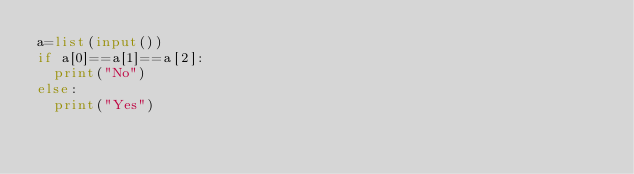<code> <loc_0><loc_0><loc_500><loc_500><_Python_>a=list(input())
if a[0]==a[1]==a[2]:
  print("No")
else:
  print("Yes")</code> 